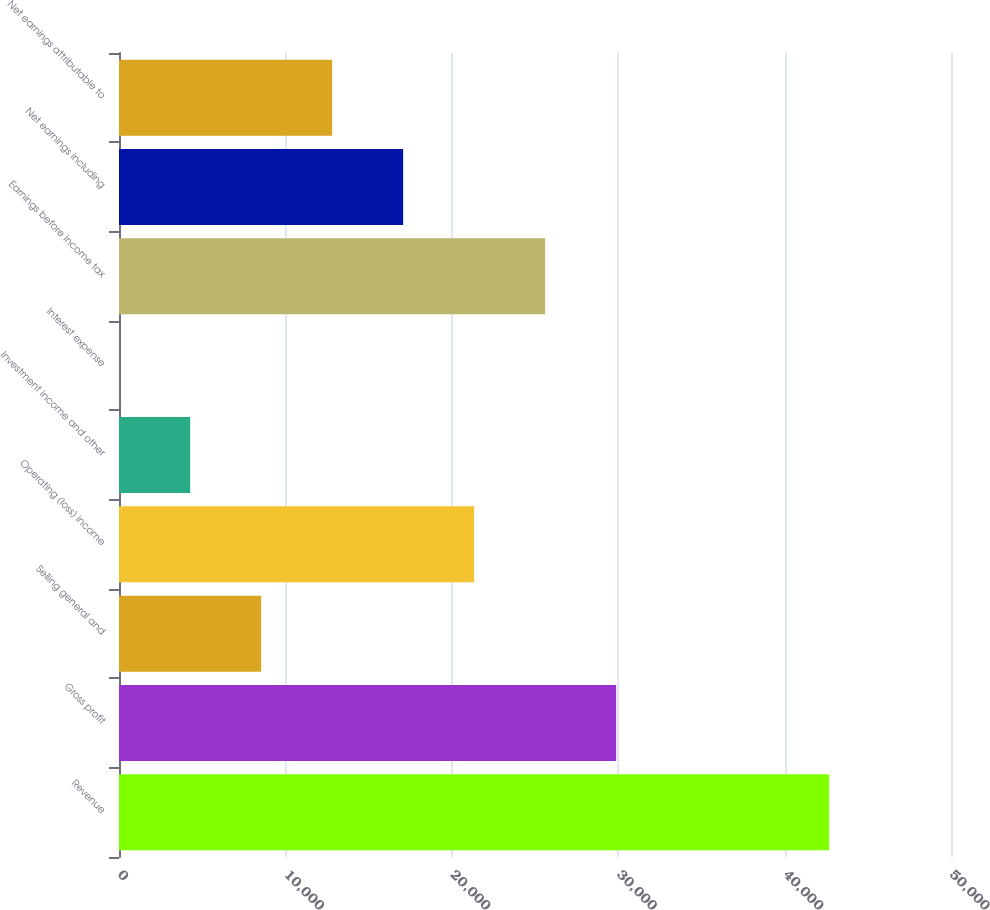<chart> <loc_0><loc_0><loc_500><loc_500><bar_chart><fcel>Revenue<fcel>Gross profit<fcel>Selling general and<fcel>Operating (loss) income<fcel>Investment income and other<fcel>Interest expense<fcel>Earnings before income tax<fcel>Net earnings including<fcel>Net earnings attributable to<nl><fcel>42677<fcel>29876.9<fcel>8543.4<fcel>21343.5<fcel>4276.7<fcel>10<fcel>25610.2<fcel>17076.8<fcel>12810.1<nl></chart> 